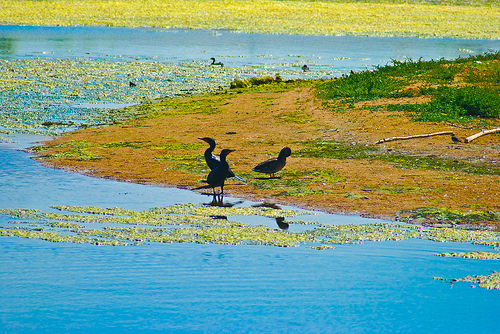<image>
Can you confirm if the bird is in the lake? No. The bird is not contained within the lake. These objects have a different spatial relationship. Where is the duck in relation to the water? Is it in the water? No. The duck is not contained within the water. These objects have a different spatial relationship. 